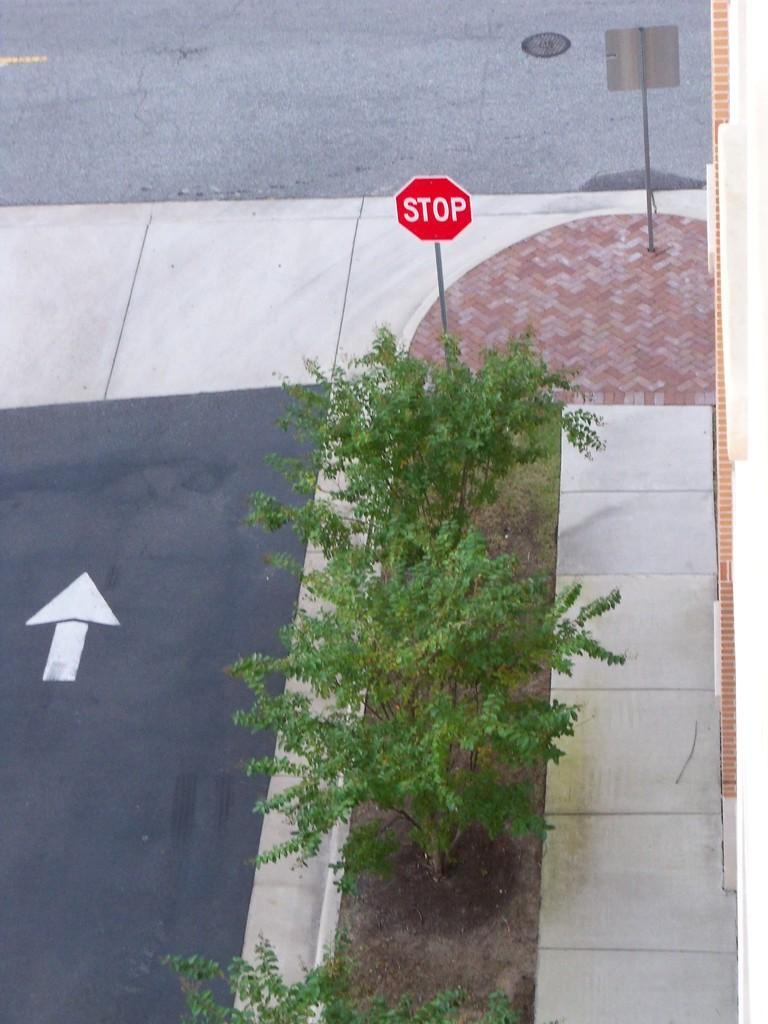<image>
Present a compact description of the photo's key features. A stop sign to the right of an upwards arrow sign. 